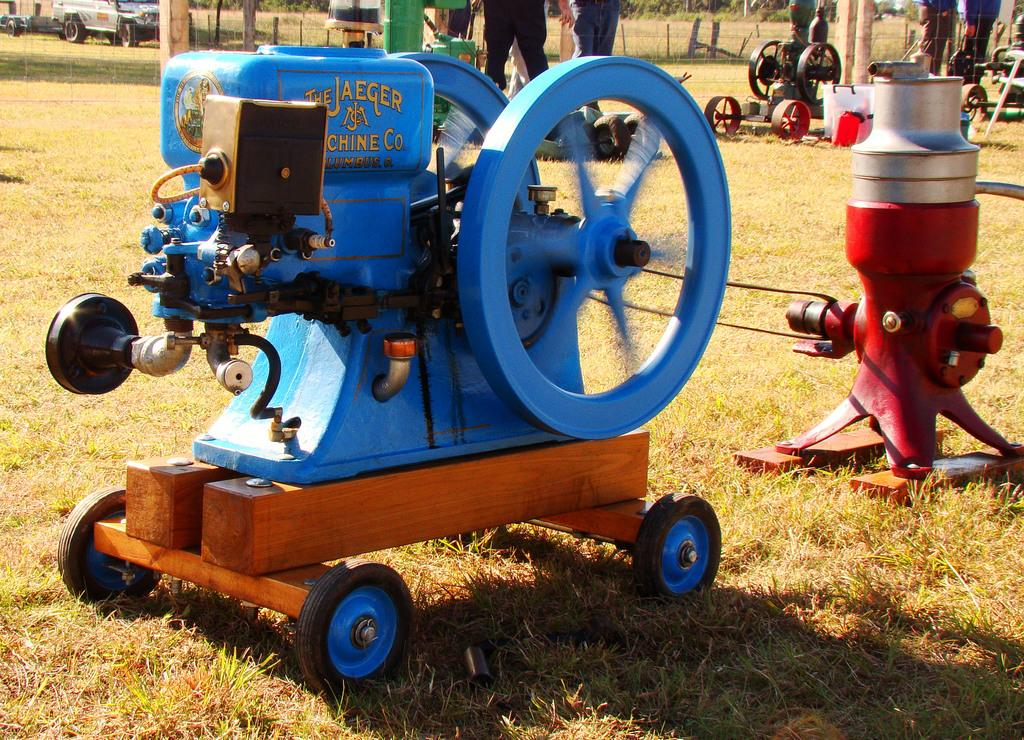What type of objects are placed on the grass in the image? There are machines on the grass in the image. What else can be seen in the image besides the machines? There are vehicles, persons, a fence, and trees in the image. Can you describe the setting where the machines are located? The machines are located on the grass, with a fence and trees visible in the background. How does the ocean affect the machines in the image? There is no ocean present in the image, so it cannot affect the machines. What type of pet can be seen interacting with the machines in the image? There are no pets present in the image, so no such interaction can be observed. 